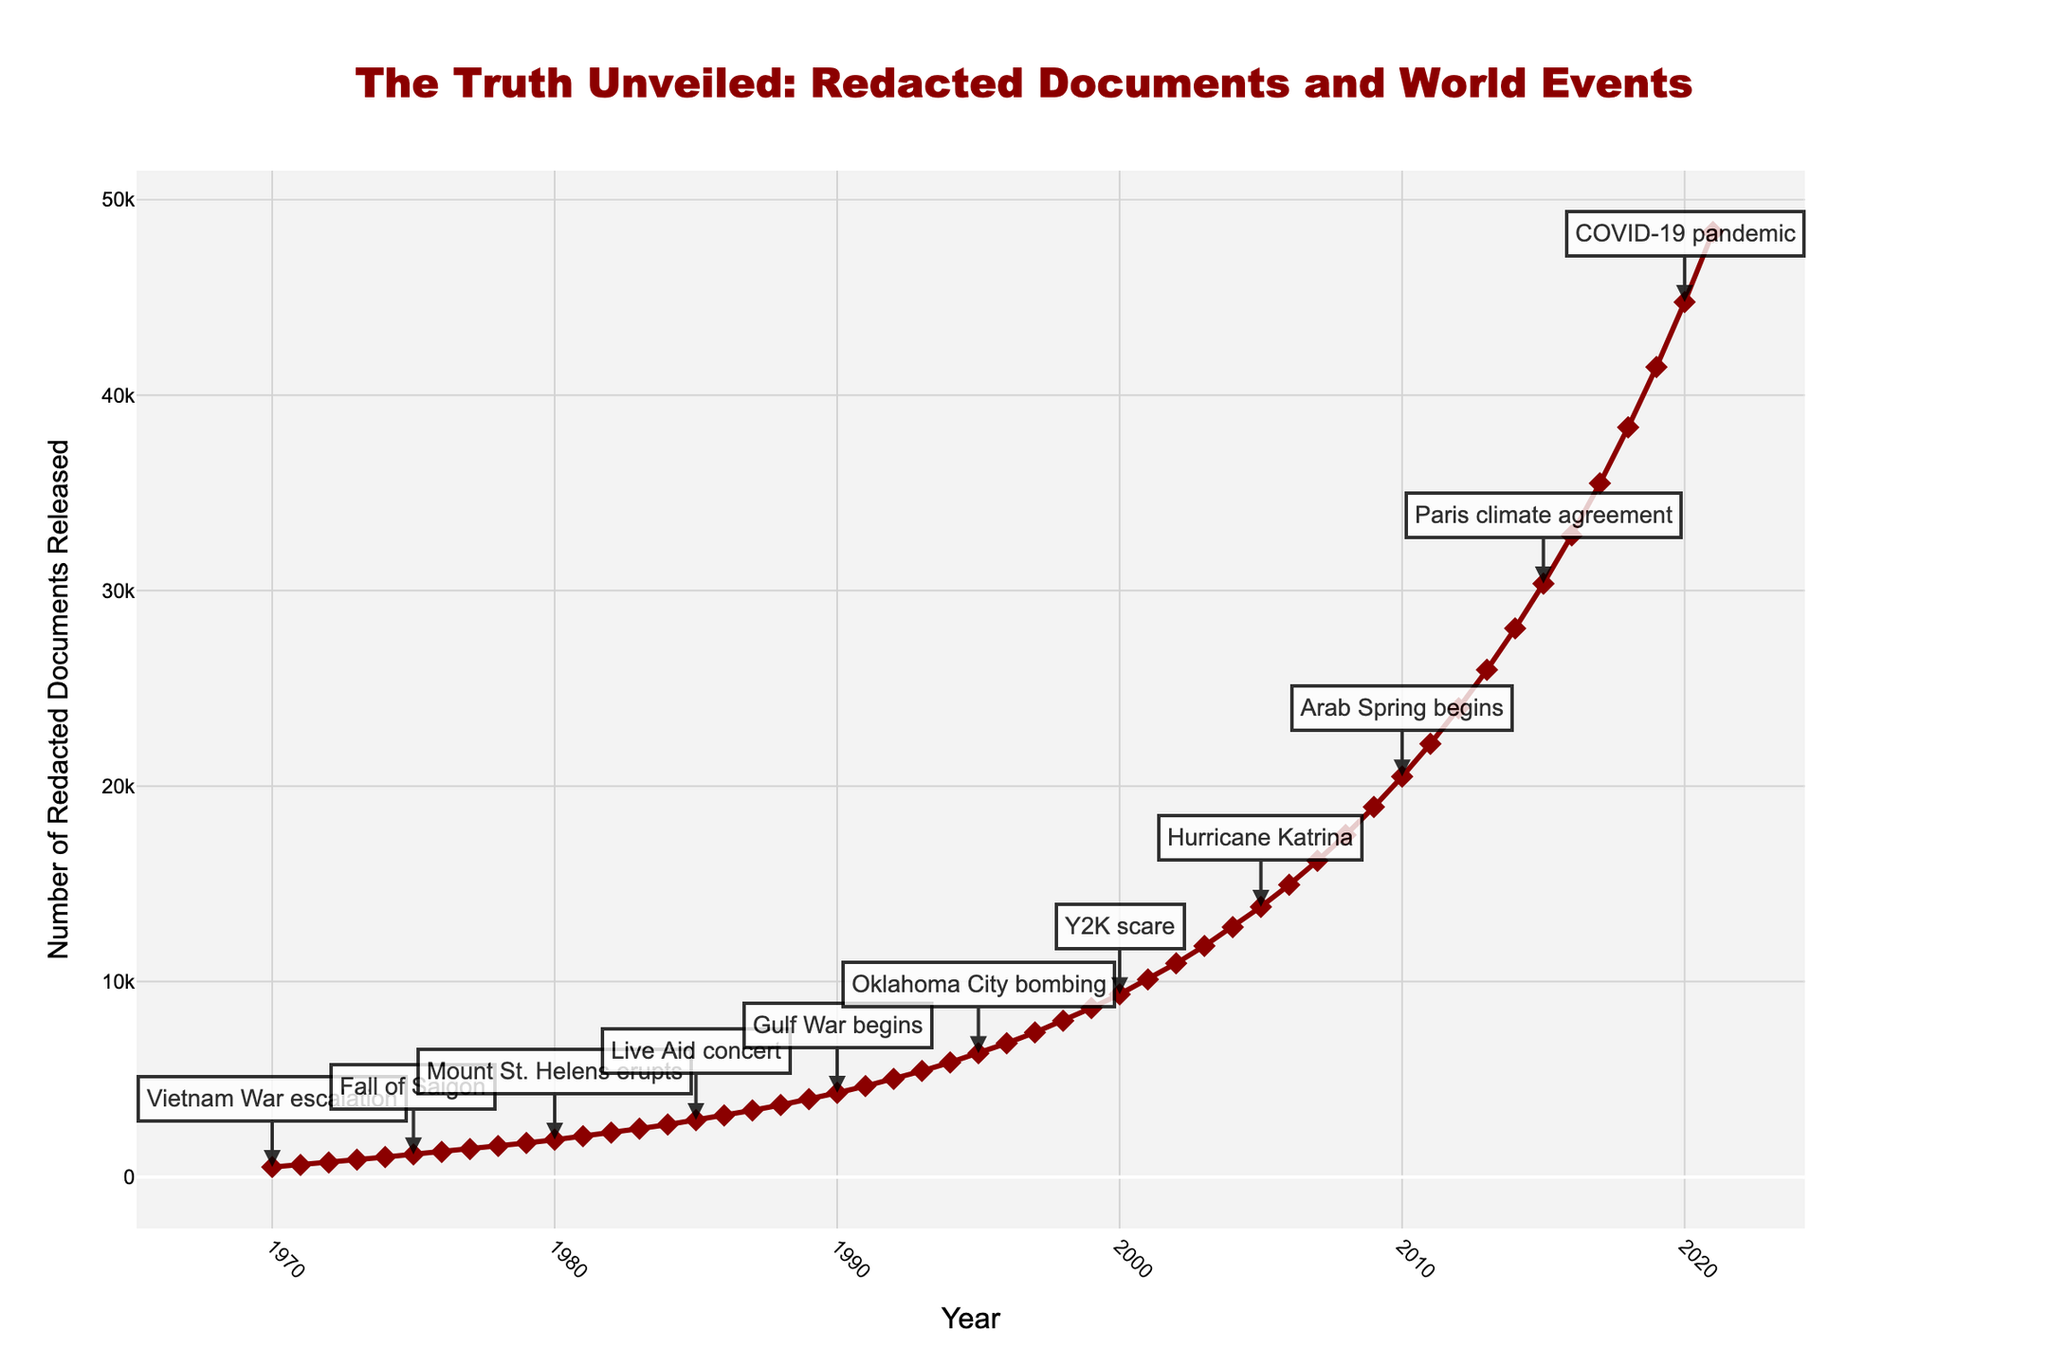What's the general trend of the number of redacted documents released from 1970 to 2021? The line chart shows a steady increase in the number of redacted documents released each year from 1970 to 2021. There are no significant drops or declines, only gradual increases each year.
Answer: Steady increase Which year saw the highest number of redacted documents released? By examining the peak of the line, the highest point corresponds to the year 2021.
Answer: 2021 What major world event corresponds with the highest number of redacted documents released? The annotation at the peak of the line for 2021 indicates that the major world event is the US Capitol riot.
Answer: US Capitol riot How does the number of redacted documents released in 2001 compare to that in 2000? The line rises from 9351 in the year 2000 to 10112 in the year 2001, indicating an increase.
Answer: Increased What is the difference in the number of redacted documents released between the start and end of the 1970s? In 1970, the number of redacted documents released was 512, and by 1979 it was 1745. The difference is 1745 - 512 = 1233.
Answer: 1233 Which event corresponds with the sharp increase in redacted documents released between 2000 and 2001? The annotation for 2001, which corresponds to the sharp increase from 9351 to 10112, indicates the September 11 attacks.
Answer: September 11 attacks Can you identify any years where the number of redacted documents released plateaued or decreased? From the graph, there are no evident years where the number of redacted documents released plateaued or decreased. Each year shows an upward trend.
Answer: No From the data, which major world event correlates with the steepest increase in the number of redacted documents released? From visual inspection, the steepest increase happens between 2019 (41438) and 2020 (44760). The event in 2020 is the COVID-19 pandemic.
Answer: COVID-19 pandemic Calculate the average number of redacted documents released per year from 1970 to 1980. Summing the numbers between 1970 and 1980 (512 + 623 + 745 + 891 + 1023 + 1156 + 1289 + 1432 + 1587 + 1745 + 1912) gives 13815. Dividing by 11 years provides the average: 13815 / 11 = 1256.36.
Answer: 1256.36 What is the visual indicator used to mark the annotations for major world events? The annotations for major world events are marked with text labels and arrows pointing to specific points on the line chart.
Answer: Text labels and arrows What is the overall pattern observed between the number of redacted documents released and major world events? Examining the line chart, it is evident that significant world events typically correspond with noticeable increases in the number of redacted documents released.
Answer: Significant events, noticeable increases 